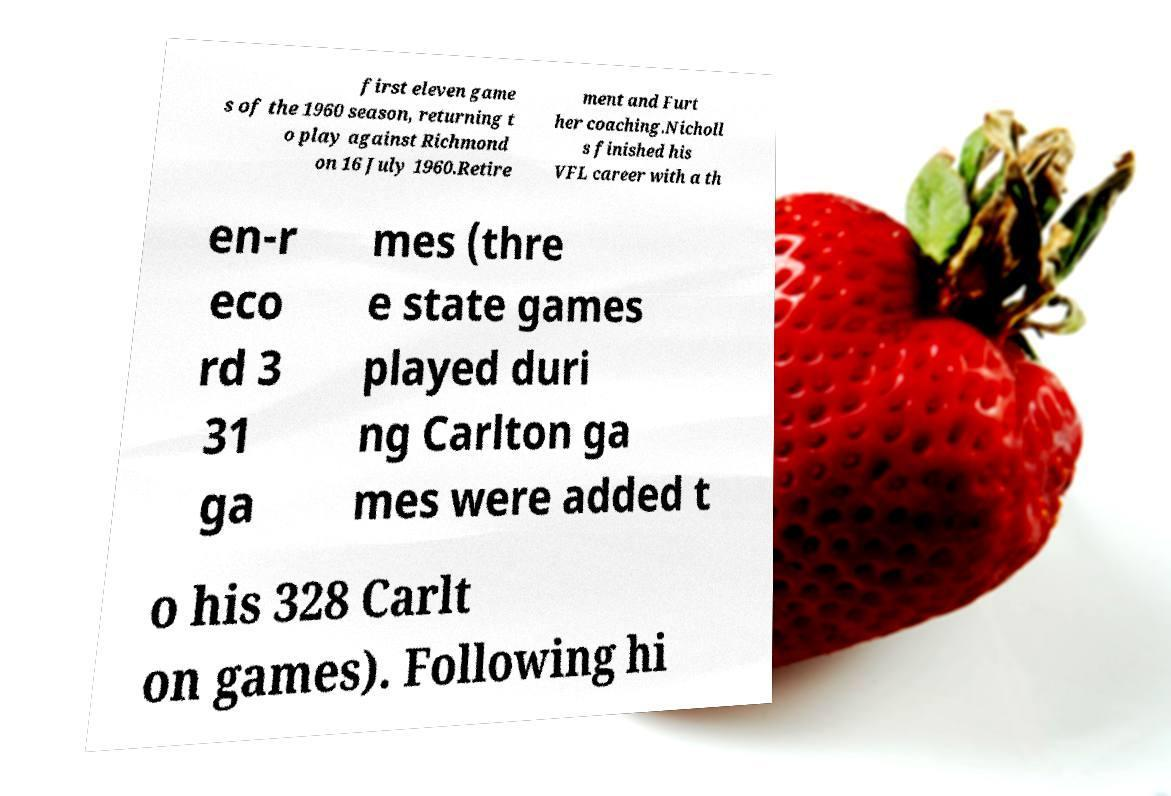Please read and relay the text visible in this image. What does it say? first eleven game s of the 1960 season, returning t o play against Richmond on 16 July 1960.Retire ment and Furt her coaching.Nicholl s finished his VFL career with a th en-r eco rd 3 31 ga mes (thre e state games played duri ng Carlton ga mes were added t o his 328 Carlt on games). Following hi 